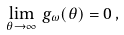<formula> <loc_0><loc_0><loc_500><loc_500>\lim _ { \theta \to \infty } \, g _ { \omega } ( \theta ) = 0 \, ,</formula> 